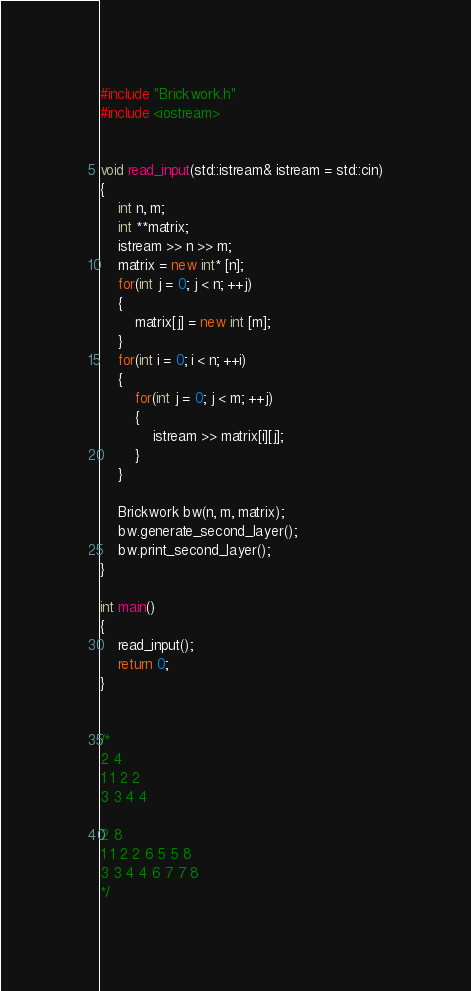<code> <loc_0><loc_0><loc_500><loc_500><_C++_>#include "Brickwork.h"
#include <iostream>


void read_input(std::istream& istream = std::cin)
{
    int n, m;
    int **matrix;
    istream >> n >> m;
    matrix = new int* [n];
    for(int j = 0; j < n; ++j)
    {
        matrix[j] = new int [m];
    }
    for(int i = 0; i < n; ++i)
    {
        for(int j = 0; j < m; ++j)
        {
            istream >> matrix[i][j];
        }
    }

    Brickwork bw(n, m, matrix);
    bw.generate_second_layer();
    bw.print_second_layer();
}

int main()
{
    read_input();
    return 0;
}


/*
2 4
1 1 2 2
3 3 4 4

2 8
1 1 2 2 6 5 5 8
3 3 4 4 6 7 7 8
*/
</code> 